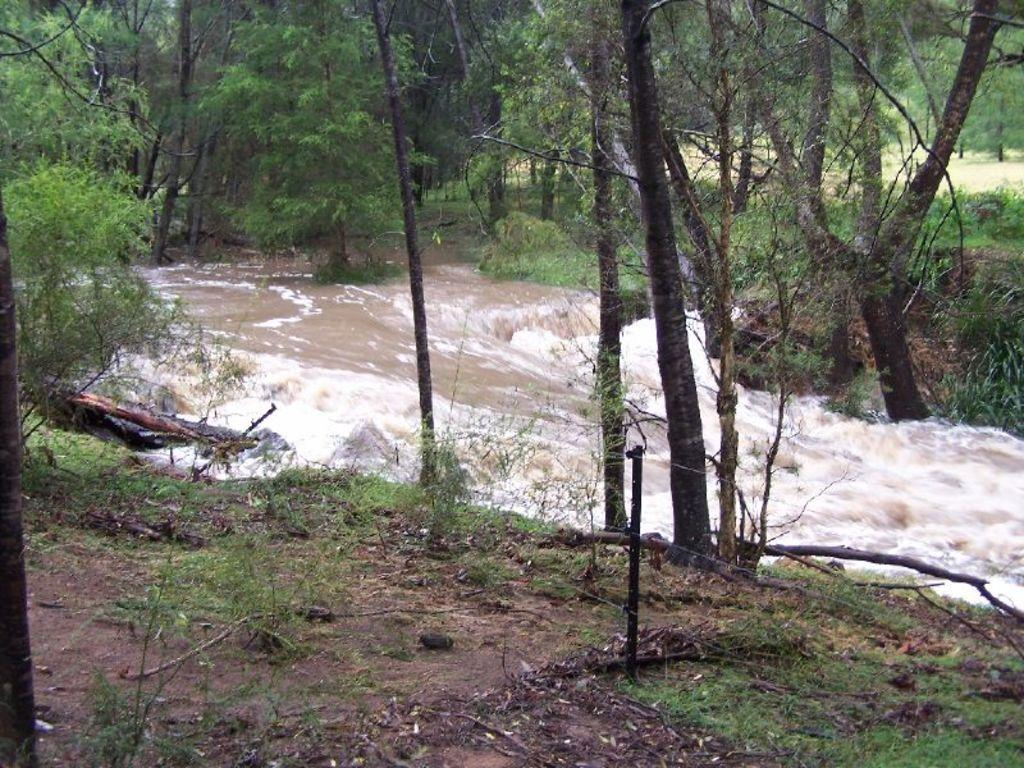What is located in the middle of the image? There is water in the middle of the image. What type of vegetation can be seen in the image? There are trees in the image. What type of gate can be seen in the image? There is no gate present in the image. What motion is depicted in the image? The image does not depict any motion; it is a still image. 